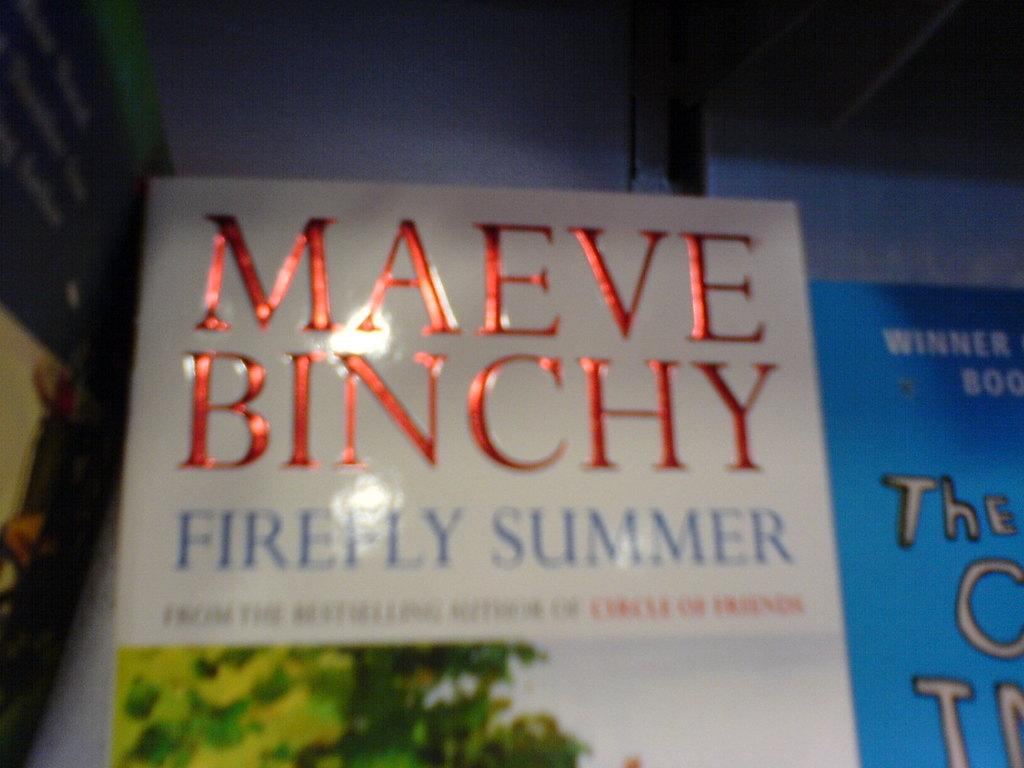<image>
Describe the image concisely. A book lying on a table with the title Firefly Summer from the author Maeve Binchy. 